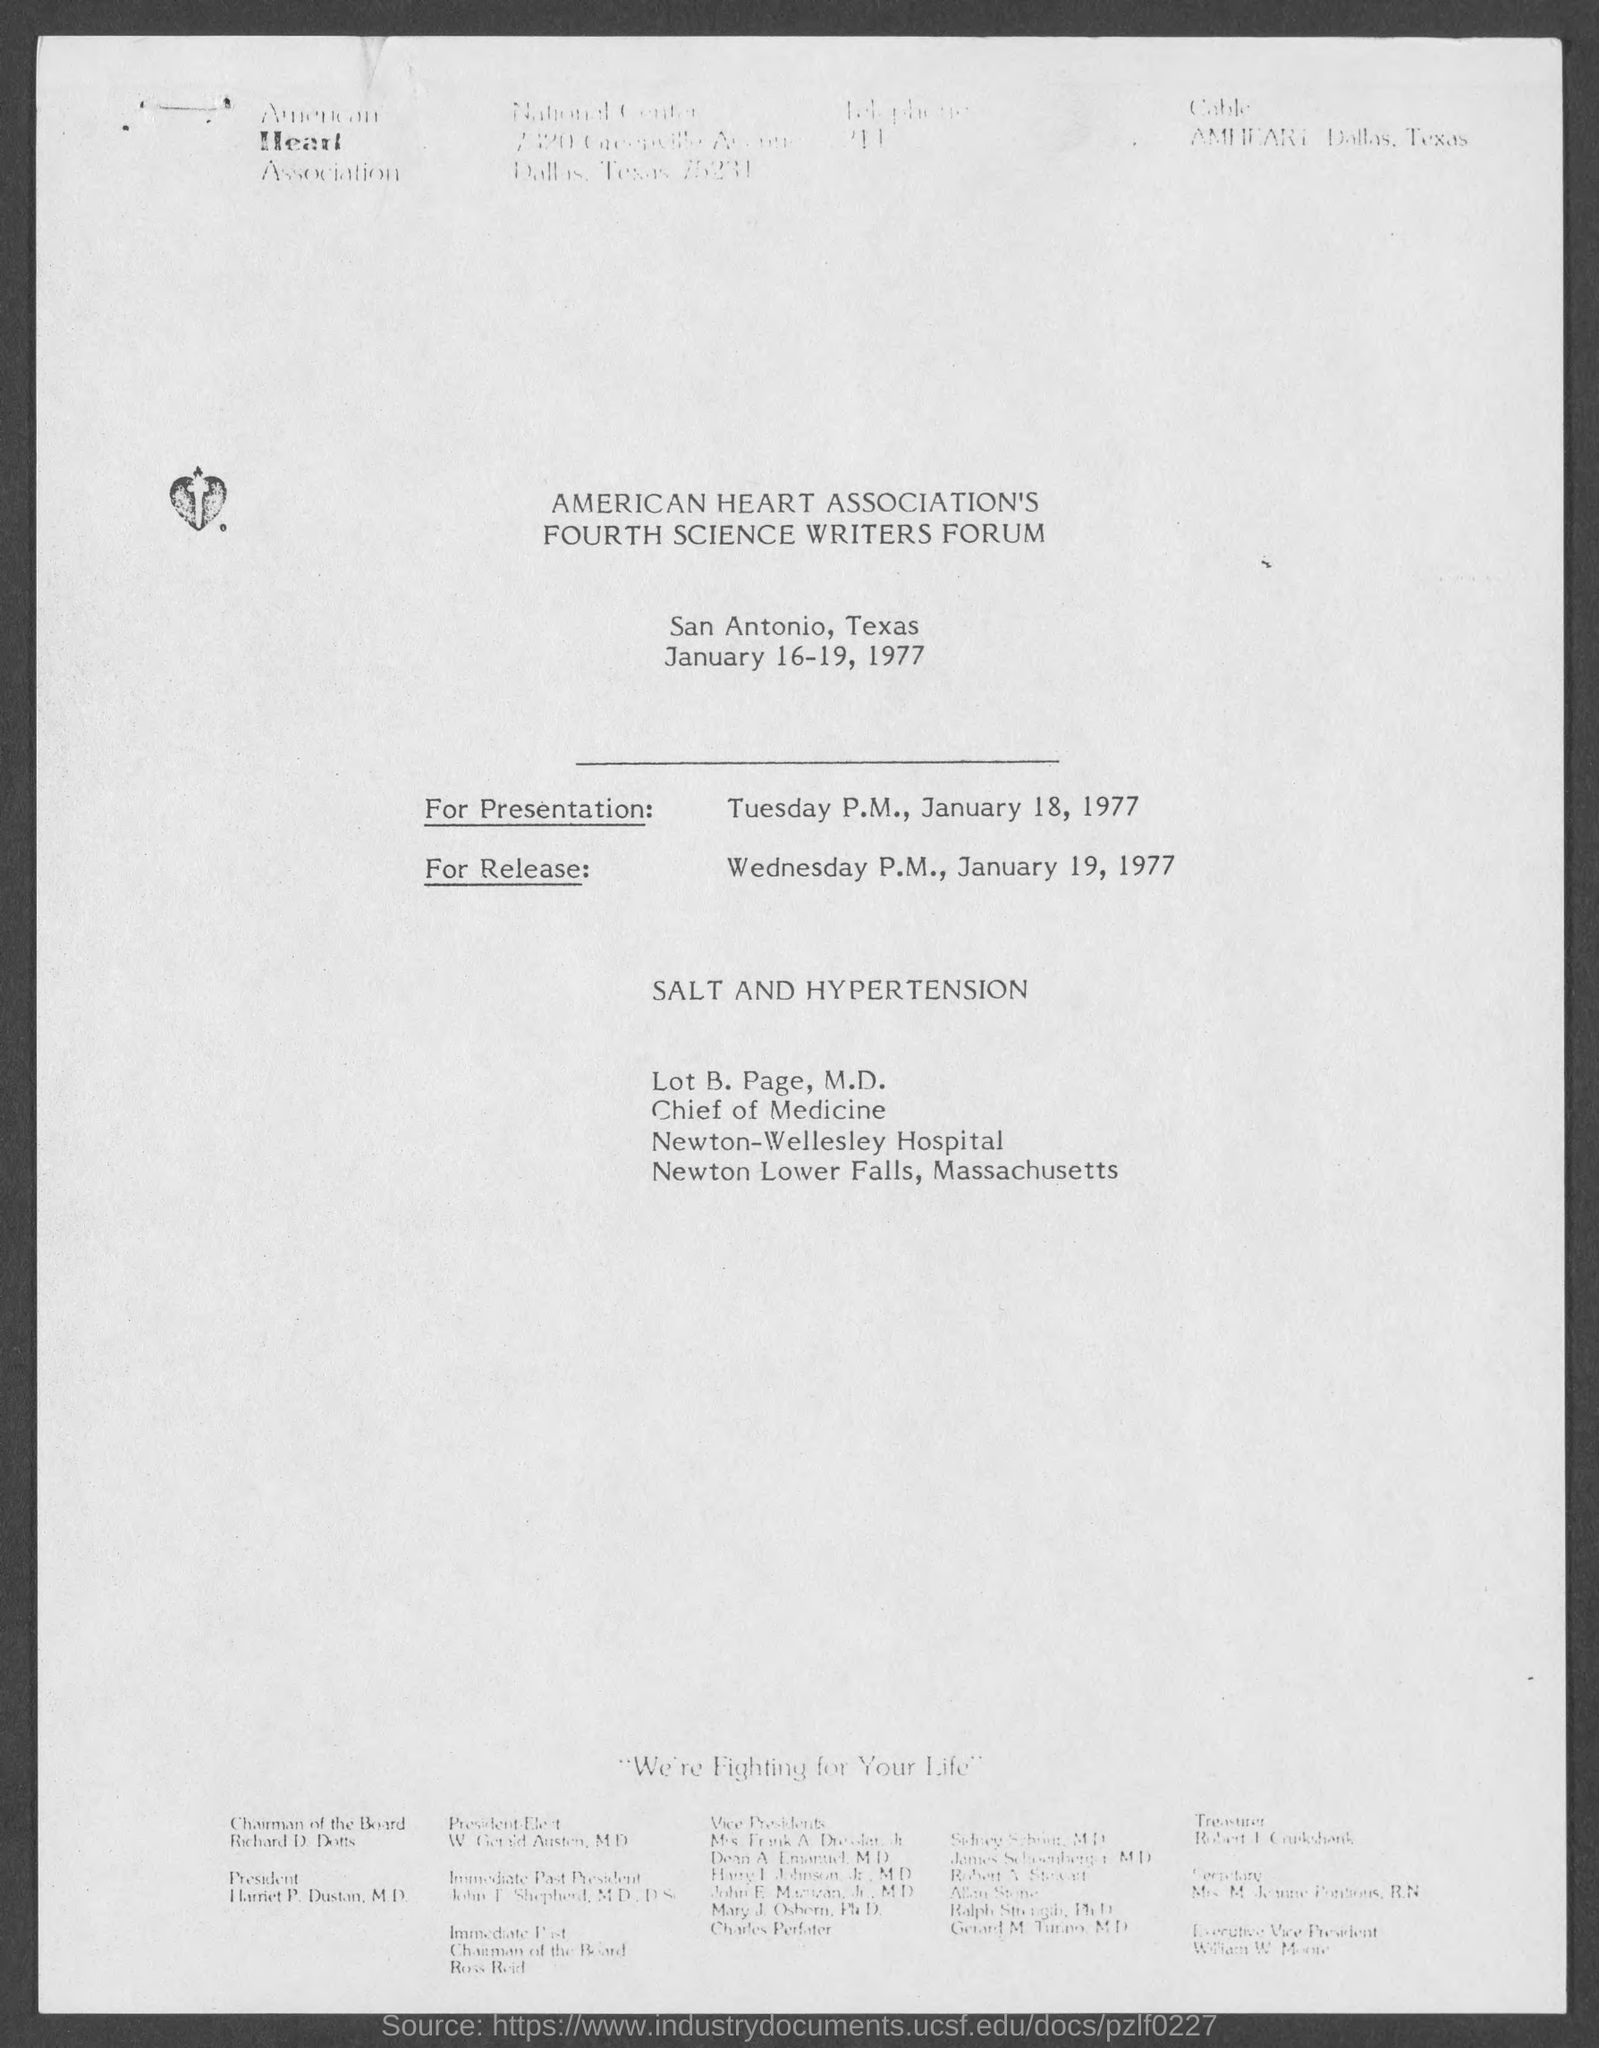When is the American Heart Association's Fourth Science Writers Forum held?
Keep it short and to the point. January 16-19, 1977. Where is the American Heart Association's Fourth Science Writers Forum held?
Offer a very short reply. San Antonio, Texas. 